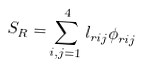Convert formula to latex. <formula><loc_0><loc_0><loc_500><loc_500>S _ { R } = \sum _ { i , j = 1 } ^ { 4 } l _ { r { i j } } \phi _ { r { i j } }</formula> 